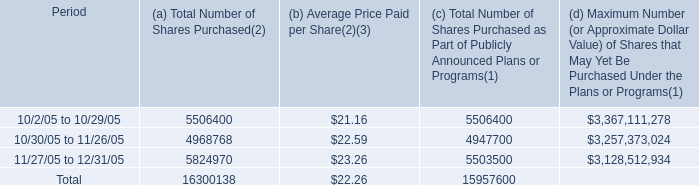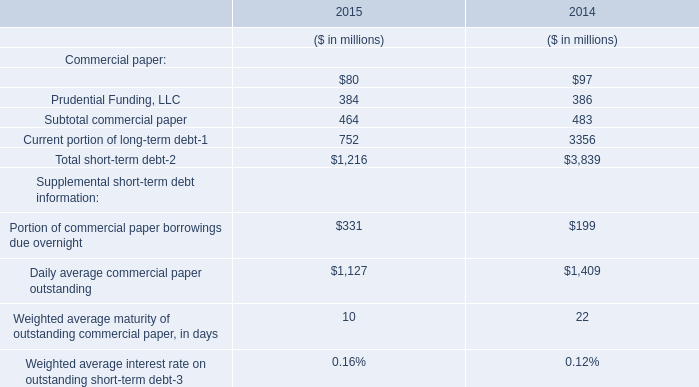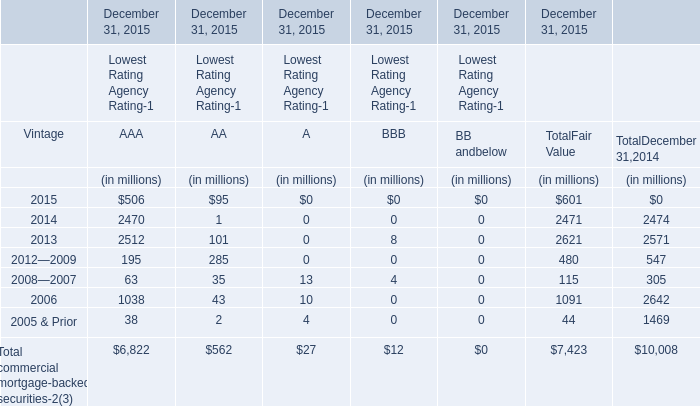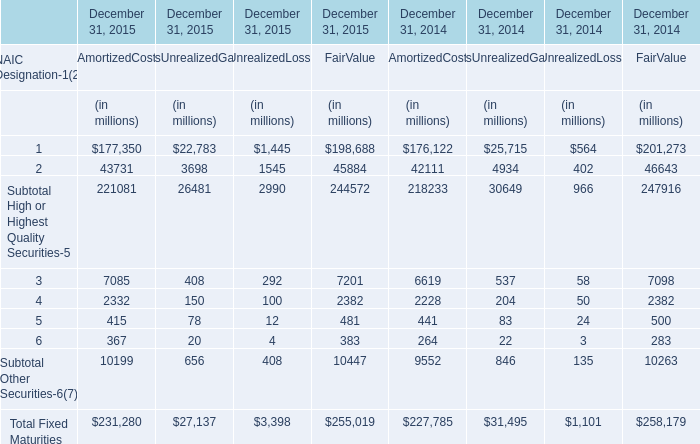What is the sum of the 5 in the years where 1 is positive? (in million) 
Computations: (((((((415 + 78) + 12) + 481) + 441) + 83) + 24) + 500)
Answer: 2034.0. 